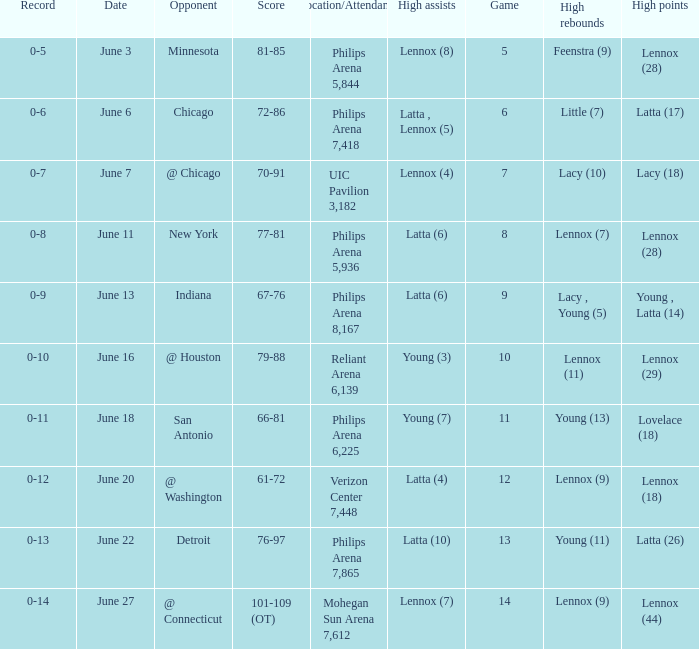Who made the highest assist in the game that scored 79-88? Young (3). 